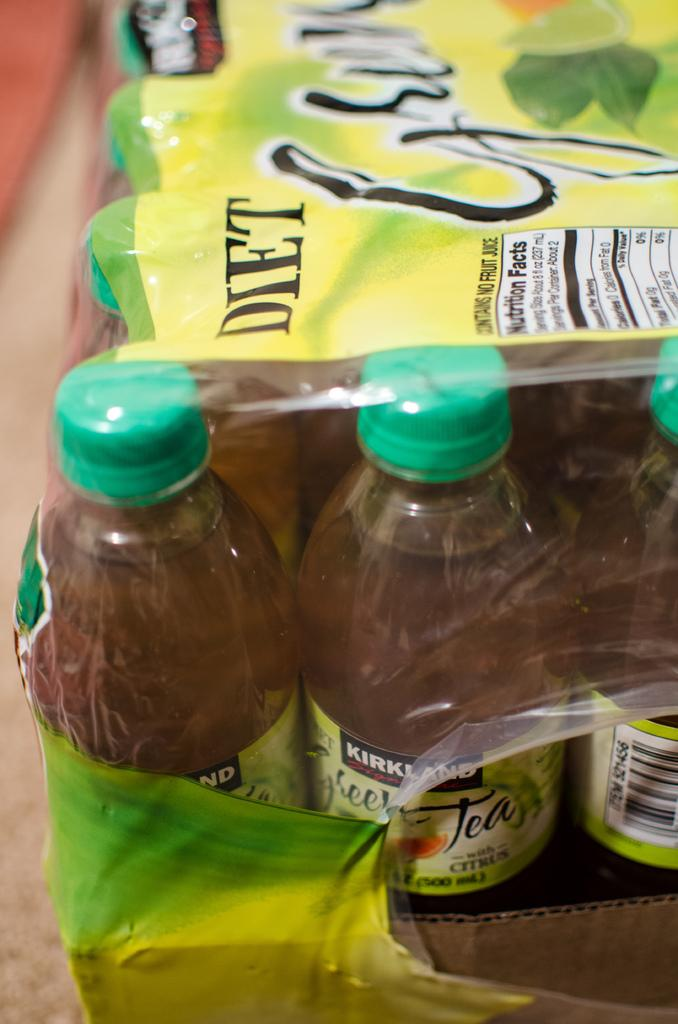<image>
Offer a succinct explanation of the picture presented. A plastic set of sweet tea bottles from the Kirkland brand. 